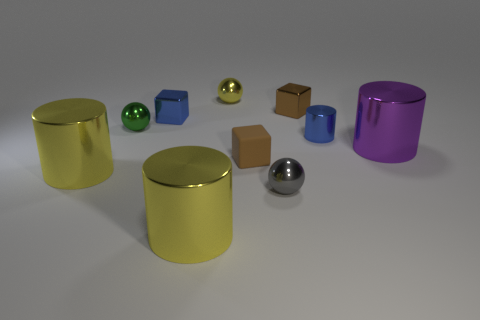Subtract 1 cylinders. How many cylinders are left? 3 Subtract all cubes. How many objects are left? 7 Add 4 small blue metal cylinders. How many small blue metal cylinders exist? 5 Subtract 1 purple cylinders. How many objects are left? 9 Subtract all big red rubber balls. Subtract all tiny green metallic things. How many objects are left? 9 Add 7 tiny blue metal cylinders. How many tiny blue metal cylinders are left? 8 